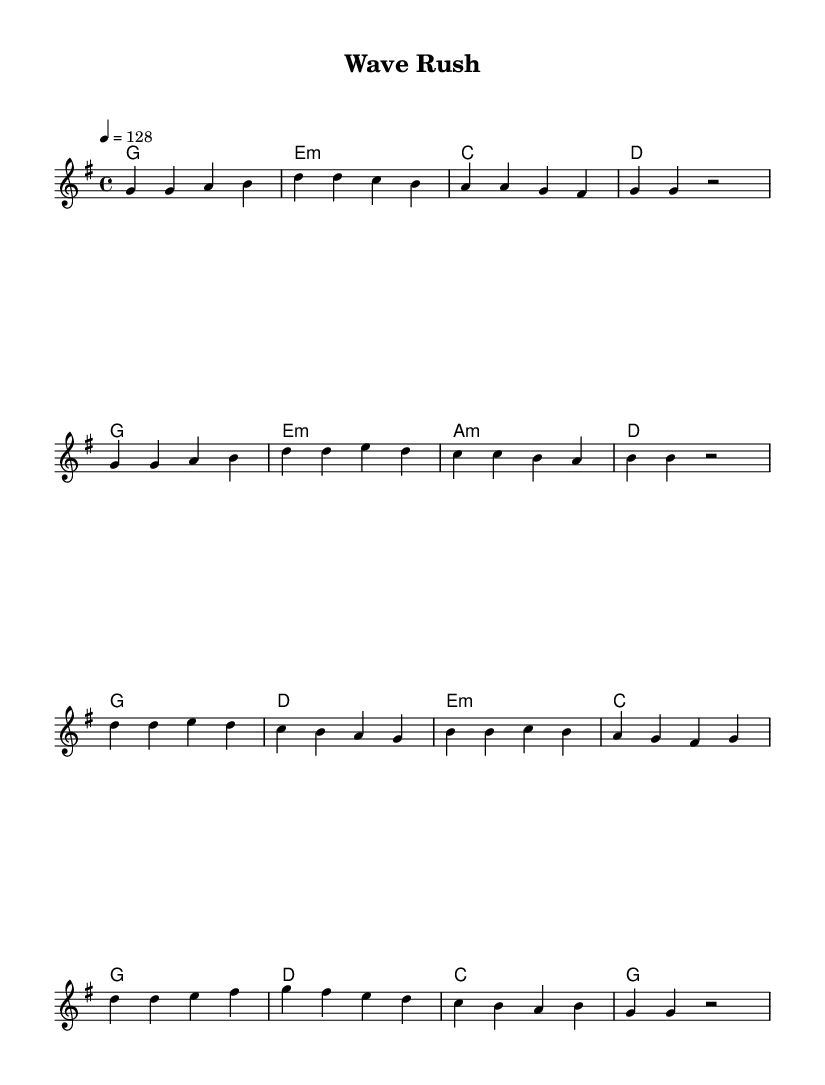What is the key signature of this music? The key signature is G major, which has one sharp (F#).
Answer: G major What is the time signature of this piece? The time signature is indicated as 4/4, meaning there are four beats per measure.
Answer: 4/4 What is the tempo marking? The tempo marking is indicated as 128 beats per minute (bpm), specified by "4 = 128".
Answer: 128 How many measures are in the verse? The verse consists of 8 measures, as indicated by the sequence of notes and rests.
Answer: 8 What is the primary mood conveyed by the melody? The melody is upbeat and energetic, characteristic of K-Pop songs, especially suitable for the thrill of wave riding.
Answer: Energetic In the chorus, what is the highest note? The highest note in the chorus is A, which appears in the line starting with "b b c b".
Answer: A What type of harmony is primarily used in the verse? The harmony primarily used is a combination of major and minor chords, reflecting the K-Pop style's dynamic sound.
Answer: Major and minor chords 